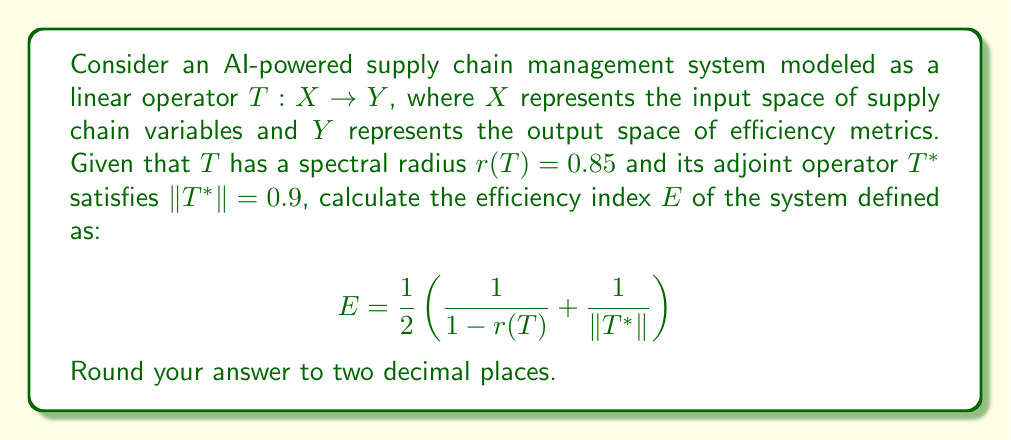What is the answer to this math problem? To solve this problem, we'll follow these steps:

1) We are given:
   - Spectral radius $r(T) = 0.85$
   - Norm of the adjoint operator $\|T^*\| = 0.9$

2) The efficiency index $E$ is defined as:

   $$E = \frac{1}{2}\left(\frac{1}{1 - r(T)} + \frac{1}{\|T^*\|}\right)$$

3) Let's calculate $\frac{1}{1 - r(T)}$ first:
   
   $$\frac{1}{1 - r(T)} = \frac{1}{1 - 0.85} = \frac{1}{0.15} = 6.6667$$

4) Now, let's calculate $\frac{1}{\|T^*\|}$:
   
   $$\frac{1}{\|T^*\|} = \frac{1}{0.9} = 1.1111$$

5) Now we can substitute these values into our equation:

   $$E = \frac{1}{2}(6.6667 + 1.1111)$$

6) Simplify:
   
   $$E = \frac{1}{2}(7.7778) = 3.8889$$

7) Rounding to two decimal places:

   $$E \approx 3.89$$

This efficiency index provides a measure of how well the AI-powered supply chain management system is performing, taking into account both the spectral properties of the system (through $r(T)$) and its operational characteristics (through $\|T^*\|$).
Answer: $E \approx 3.89$ 